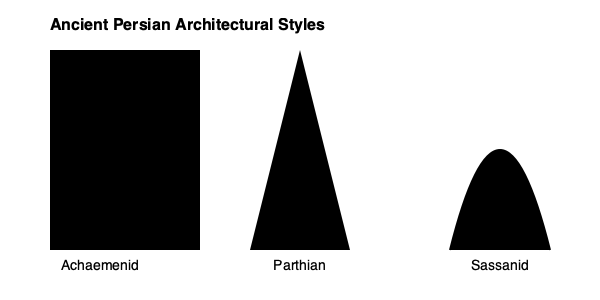Which ancient Persian architectural style is characterized by a distinctive dome-like silhouette, reflecting the advanced vaulting techniques developed during its era? To answer this question, let's analyze the silhouettes presented in the diagram:

1. Achaemenid style: Represented by a rectangular shape, indicative of the grand columned halls and square-based structures like those found in Persepolis.

2. Parthian style: Shown as a triangular shape, suggesting the development of vaulted structures but still maintaining a more angular profile.

3. Sassanid style: Depicted with a curved, dome-like silhouette. This reflects the significant advancements in vaulting techniques during the Sassanid period.

The Sassanid Empire (224-651 CE) saw remarkable developments in architecture, particularly in the construction of domes. They perfected the technique of building large-scale domes, which became a hallmark of their architectural style. This innovation allowed for the creation of vast, open interior spaces and became a significant influence on later Islamic architecture.

The dome-like silhouette in the diagram clearly represents this Sassanid architectural innovation, distinguishing it from the earlier Achaemenid and Parthian styles.
Answer: Sassanid 